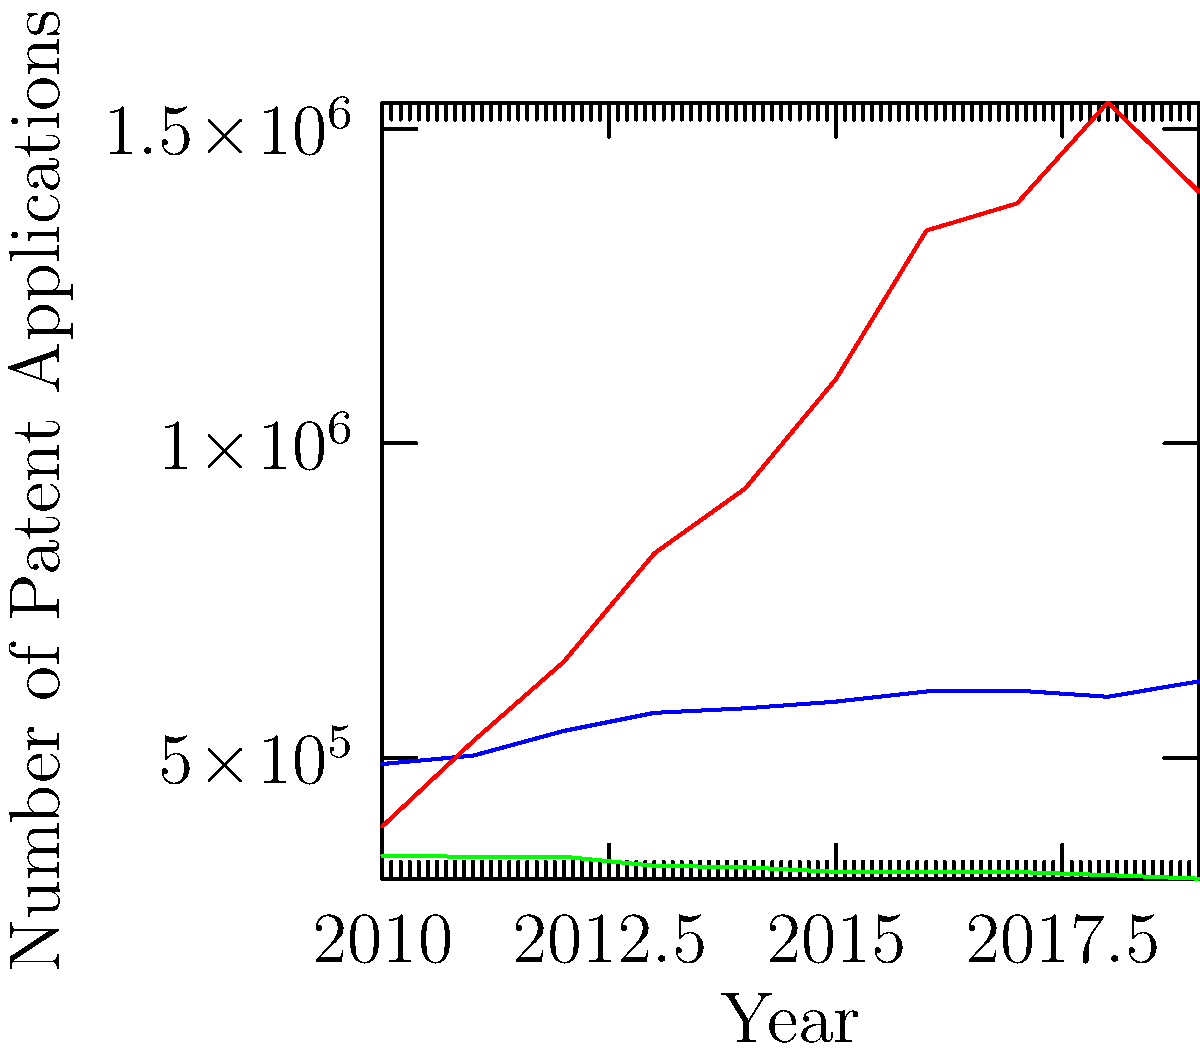Based on the line graph showing patent application rates in the USA, China, and Japan from 2010 to 2019, which country experienced the most significant increase in patent applications during this period, and what implications might this have for global IP harmonization efforts? To answer this question, we need to analyze the trends for each country:

1. USA: Shows a gradual increase from 2010 to 2019, rising from about 490,000 to 620,000 applications.

2. Japan: Displays a slight decline over the period, decreasing from approximately 345,000 to 308,000 applications.

3. China: Exhibits the most dramatic increase, starting at around 391,000 in 2010 and reaching about 1,400,000 by 2019.

China clearly experienced the most significant increase in patent applications during this period. The implications for global IP harmonization efforts could include:

1. Increased pressure on the global patent system to handle a larger volume of applications, particularly from China.

2. A shift in the balance of intellectual property power, potentially giving China more influence in international IP discussions and policy-making.

3. The need for other countries to adapt their IP strategies and policies to remain competitive in the global innovation landscape.

4. Challenges in harmonizing IP laws and procedures across jurisdictions with vastly different application volumes and growth rates.

5. Potential strain on resources for patent offices worldwide, especially those processing international patent applications.

6. Increased importance of bilateral and multilateral agreements between China and other major patent-filing countries to streamline cross-border IP protection.

This trend underscores the need for more robust international cooperation in IP law harmonization to ensure efficient and effective global patent protection.
Answer: China; implications include increased pressure on global patent systems, shift in IP influence, need for policy adaptations, harmonization challenges, resource strains, and emphasis on international cooperation. 